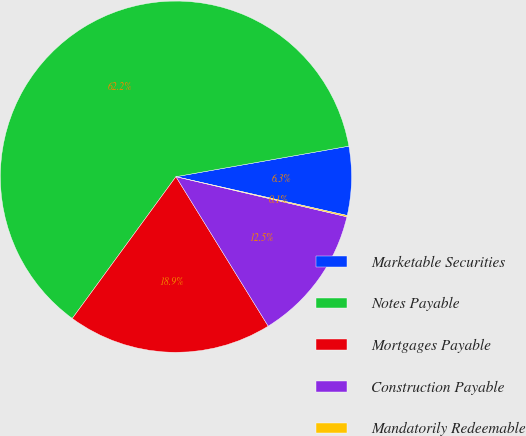Convert chart to OTSL. <chart><loc_0><loc_0><loc_500><loc_500><pie_chart><fcel>Marketable Securities<fcel>Notes Payable<fcel>Mortgages Payable<fcel>Construction Payable<fcel>Mandatorily Redeemable<nl><fcel>6.33%<fcel>62.17%<fcel>18.85%<fcel>12.53%<fcel>0.12%<nl></chart> 